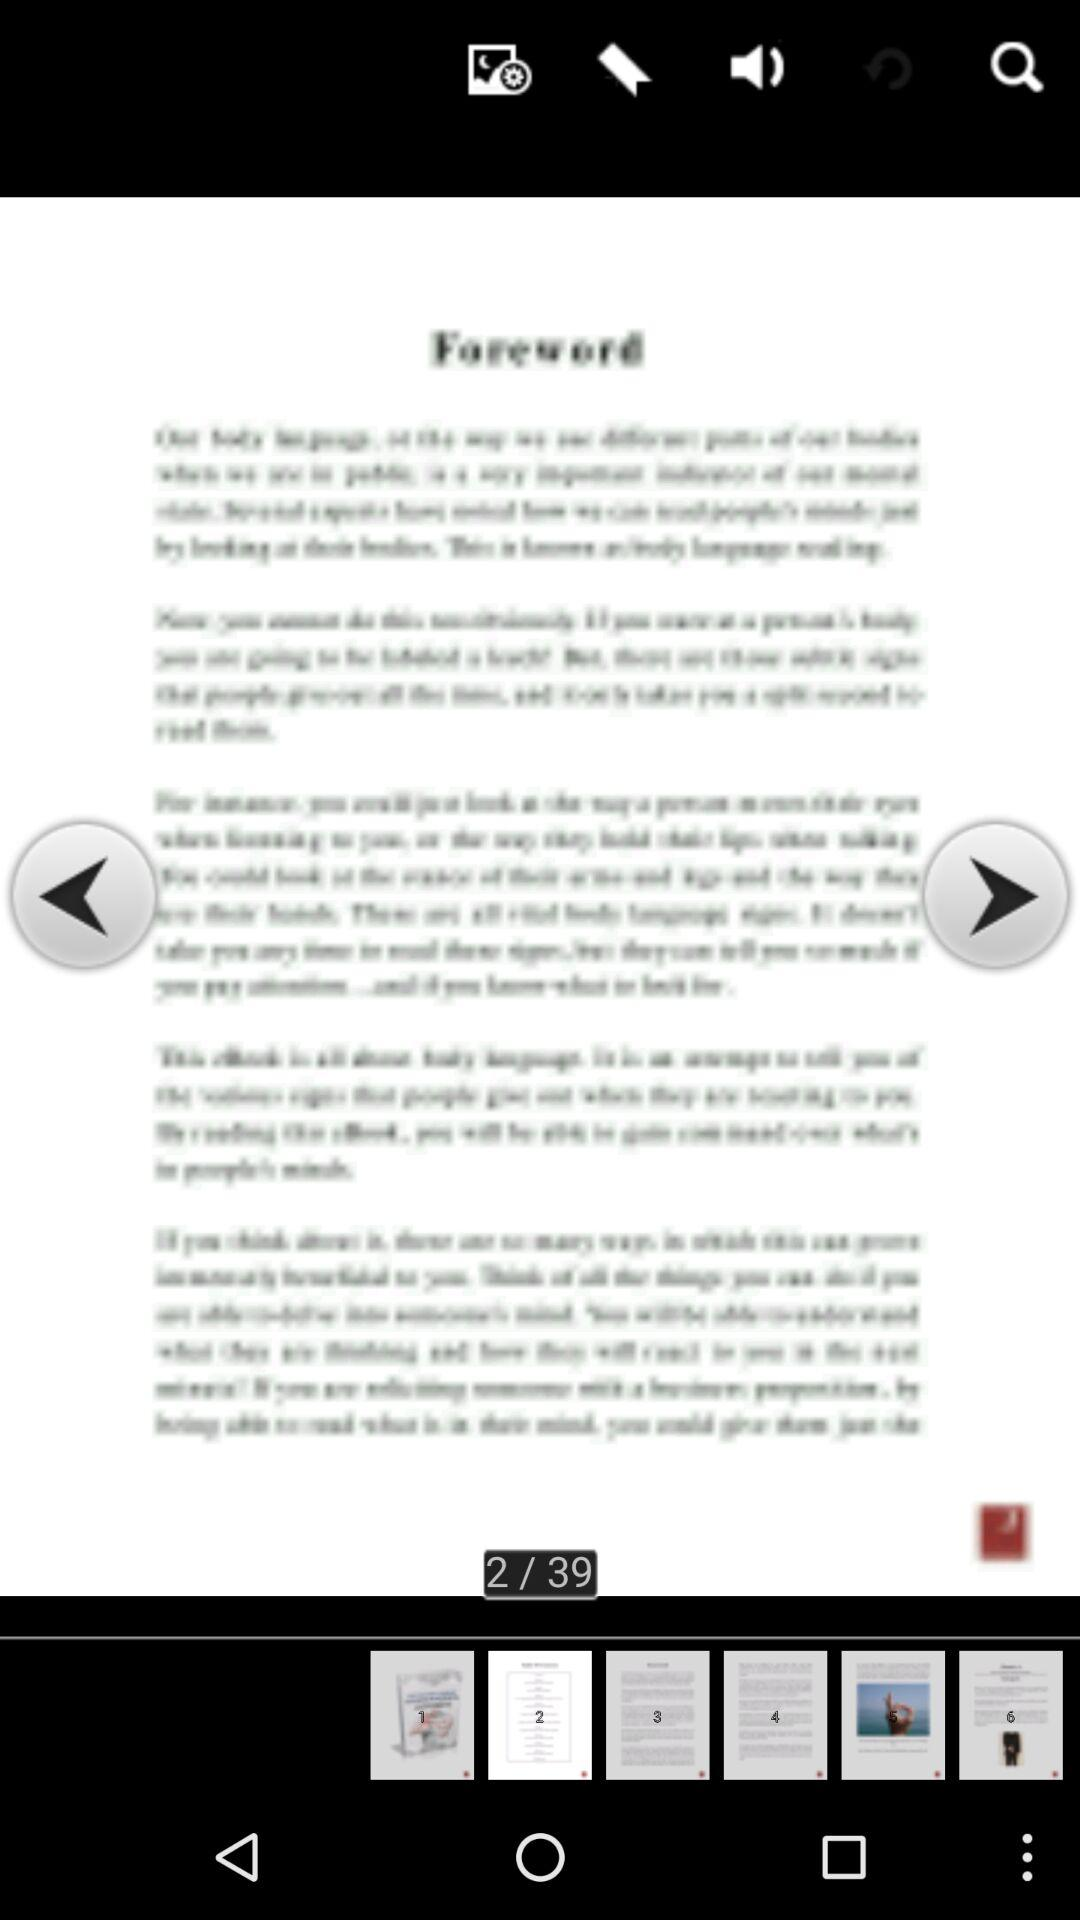What is the total page number available on the screen? The total page number available on the screen is 39. 